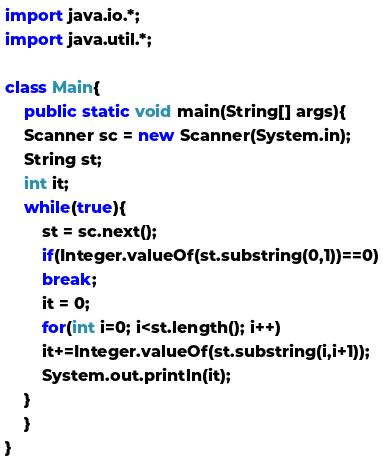<code> <loc_0><loc_0><loc_500><loc_500><_Java_>import java.io.*;
import java.util.*;

class Main{
    public static void main(String[] args){
	Scanner sc = new Scanner(System.in);
	String st;
	int it;
	while(true){
	    st = sc.next();
	    if(Integer.valueOf(st.substring(0,1))==0)
		break;
	    it = 0;
	    for(int i=0; i<st.length(); i++)
		it+=Integer.valueOf(st.substring(i,i+1));
	    System.out.println(it);
	}
    }
}</code> 